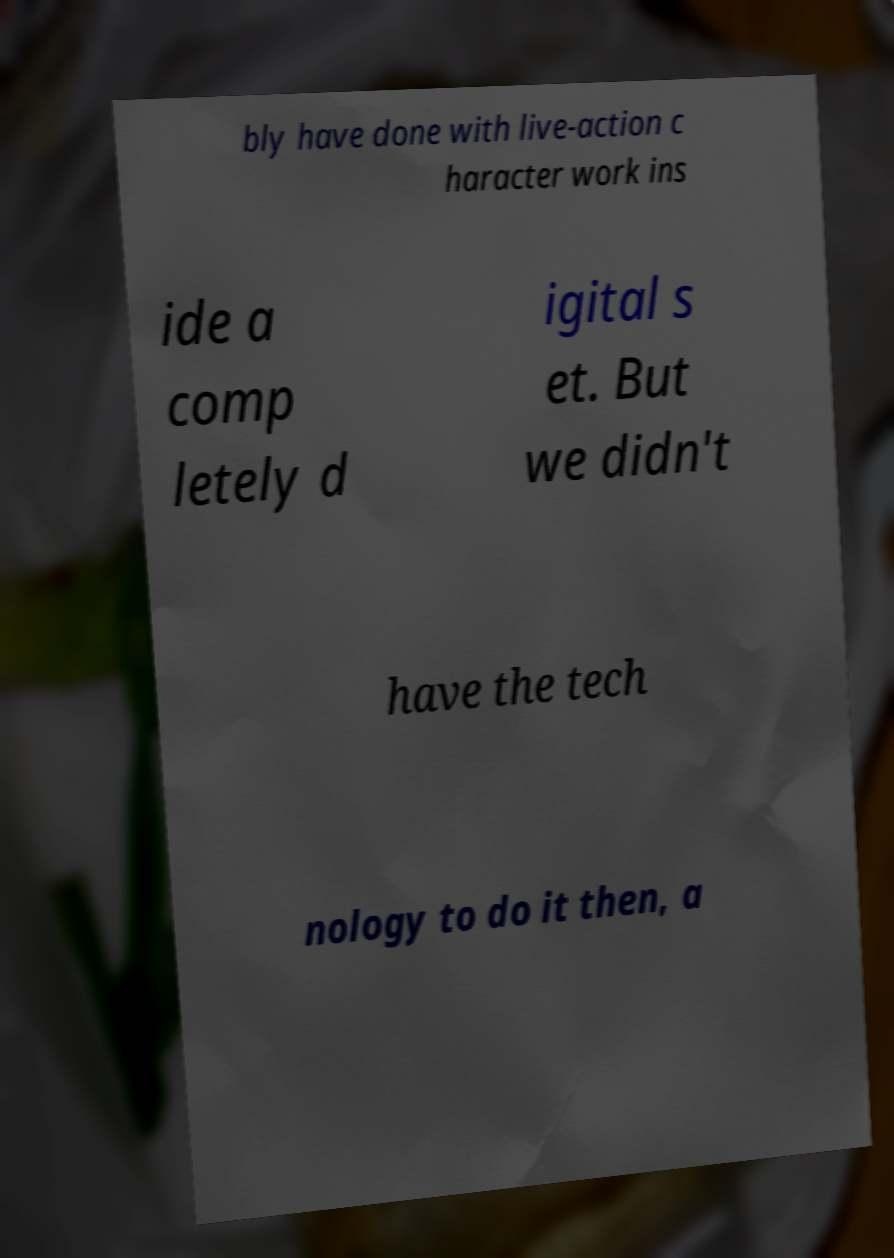For documentation purposes, I need the text within this image transcribed. Could you provide that? bly have done with live-action c haracter work ins ide a comp letely d igital s et. But we didn't have the tech nology to do it then, a 